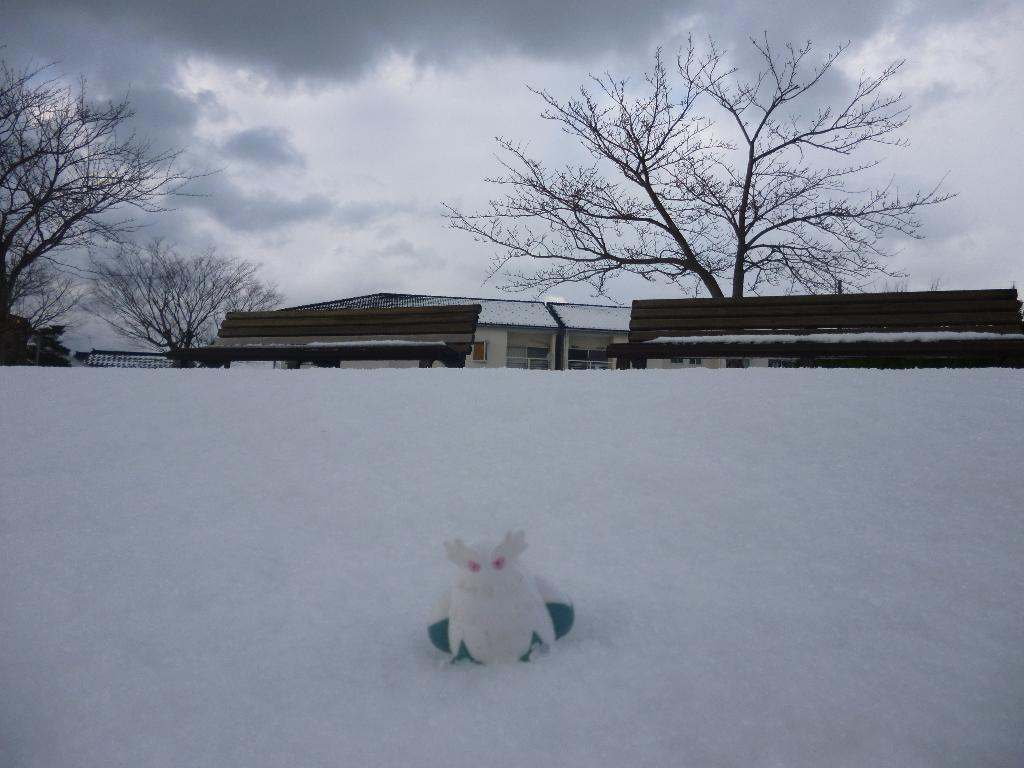What type of object can be seen in the image? There is a stuffed toy in the image. What is the ground made of in the image? There is snow at the bottom of the image. What can be seen in the background of the image? There are trees and buildings in the background of the image. What is visible at the top of the image? The sky is visible at the top of the image, and clouds are present in the sky. Can you tell me how many squirrels are sitting on the back of the stuffed toy in the image? There are no squirrels present in the image, and the stuffed toy does not have a back. What arithmetic problem can be solved using the clouds in the image? There is no arithmetic problem related to the clouds in the image, as they are simply a part of the natural environment. 